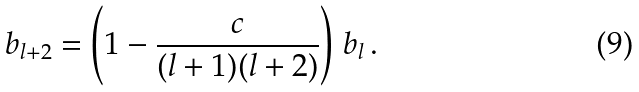Convert formula to latex. <formula><loc_0><loc_0><loc_500><loc_500>b _ { l + 2 } = \left ( 1 - \frac { c } { ( l + 1 ) ( l + 2 ) } \right ) \, b _ { l } \, .</formula> 